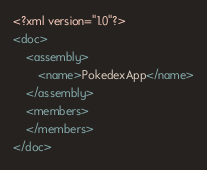<code> <loc_0><loc_0><loc_500><loc_500><_XML_><?xml version="1.0"?>
<doc>
    <assembly>
        <name>PokedexApp</name>
    </assembly>
    <members>
    </members>
</doc>
</code> 